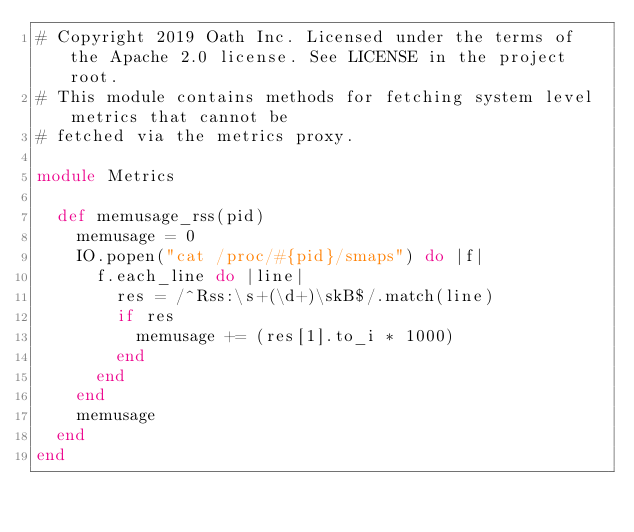Convert code to text. <code><loc_0><loc_0><loc_500><loc_500><_Ruby_># Copyright 2019 Oath Inc. Licensed under the terms of the Apache 2.0 license. See LICENSE in the project root.
# This module contains methods for fetching system level metrics that cannot be
# fetched via the metrics proxy.

module Metrics

  def memusage_rss(pid)
    memusage = 0
    IO.popen("cat /proc/#{pid}/smaps") do |f|
      f.each_line do |line|
        res = /^Rss:\s+(\d+)\skB$/.match(line)
        if res
          memusage += (res[1].to_i * 1000)
        end
      end
    end
    memusage
  end
end
</code> 